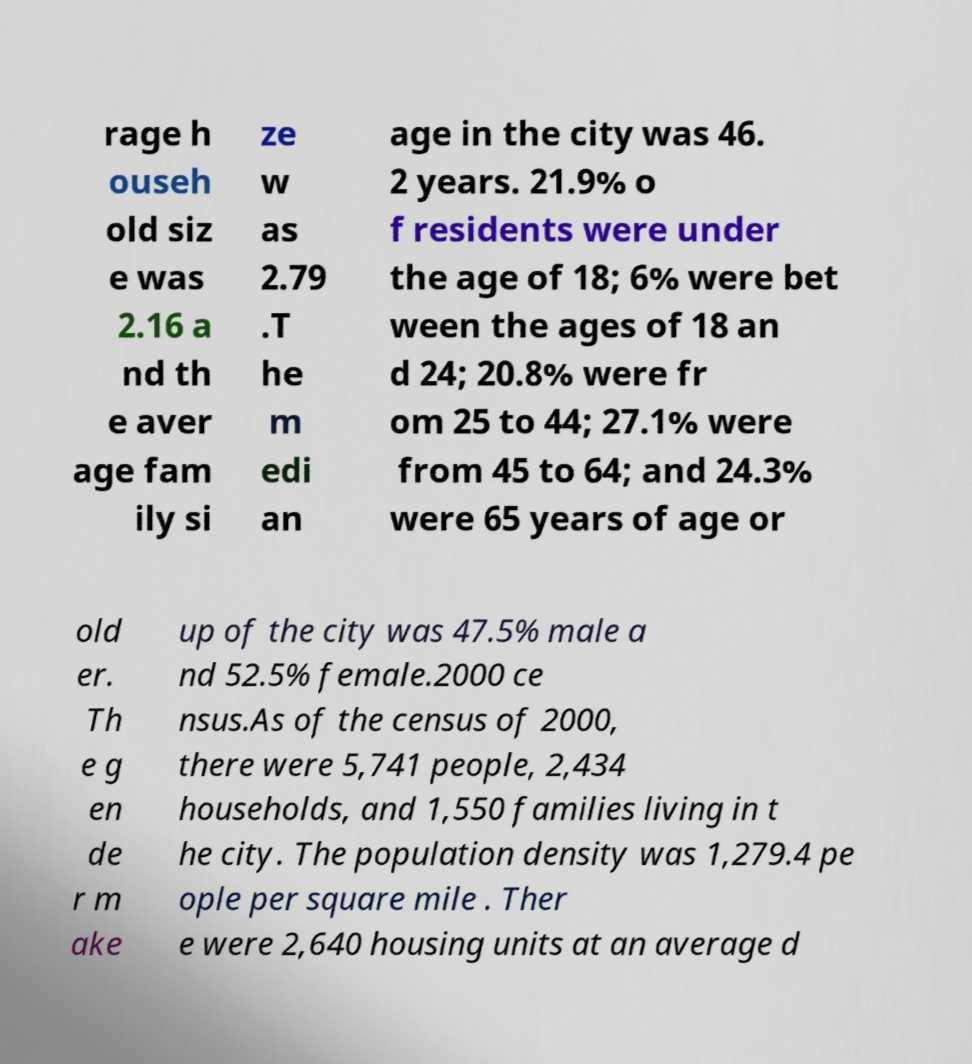I need the written content from this picture converted into text. Can you do that? rage h ouseh old siz e was 2.16 a nd th e aver age fam ily si ze w as 2.79 .T he m edi an age in the city was 46. 2 years. 21.9% o f residents were under the age of 18; 6% were bet ween the ages of 18 an d 24; 20.8% were fr om 25 to 44; 27.1% were from 45 to 64; and 24.3% were 65 years of age or old er. Th e g en de r m ake up of the city was 47.5% male a nd 52.5% female.2000 ce nsus.As of the census of 2000, there were 5,741 people, 2,434 households, and 1,550 families living in t he city. The population density was 1,279.4 pe ople per square mile . Ther e were 2,640 housing units at an average d 